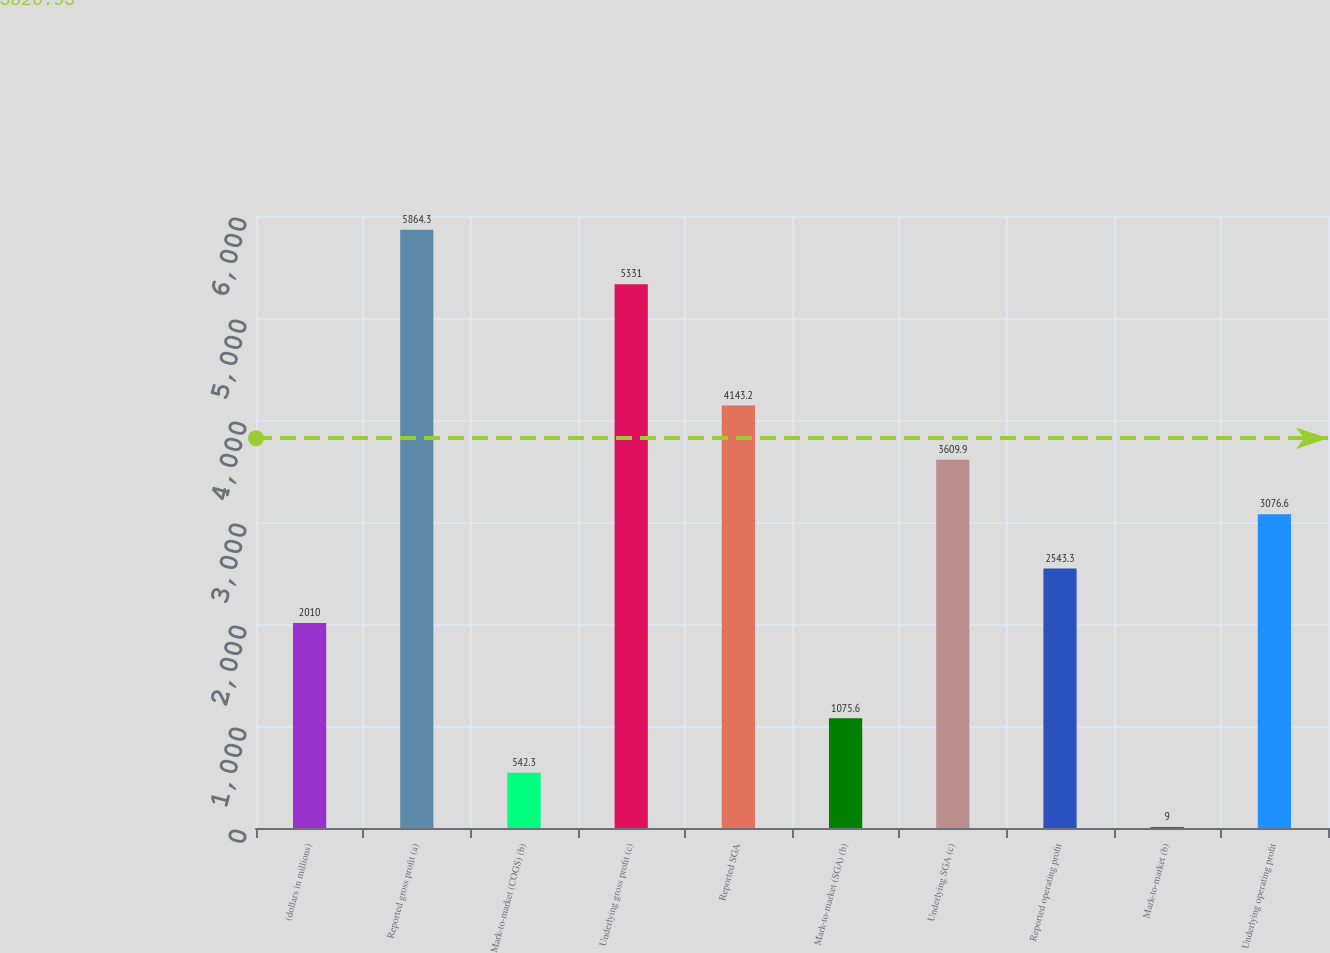Convert chart. <chart><loc_0><loc_0><loc_500><loc_500><bar_chart><fcel>(dollars in millions)<fcel>Reported gross profit (a)<fcel>Mark-to-market (COGS) (b)<fcel>Underlying gross profit (c)<fcel>Reported SGA<fcel>Mark-to-market (SGA) (b)<fcel>Underlying SGA (c)<fcel>Reported operating profit<fcel>Mark-to-market (b)<fcel>Underlying operating profit<nl><fcel>2010<fcel>5864.3<fcel>542.3<fcel>5331<fcel>4143.2<fcel>1075.6<fcel>3609.9<fcel>2543.3<fcel>9<fcel>3076.6<nl></chart> 